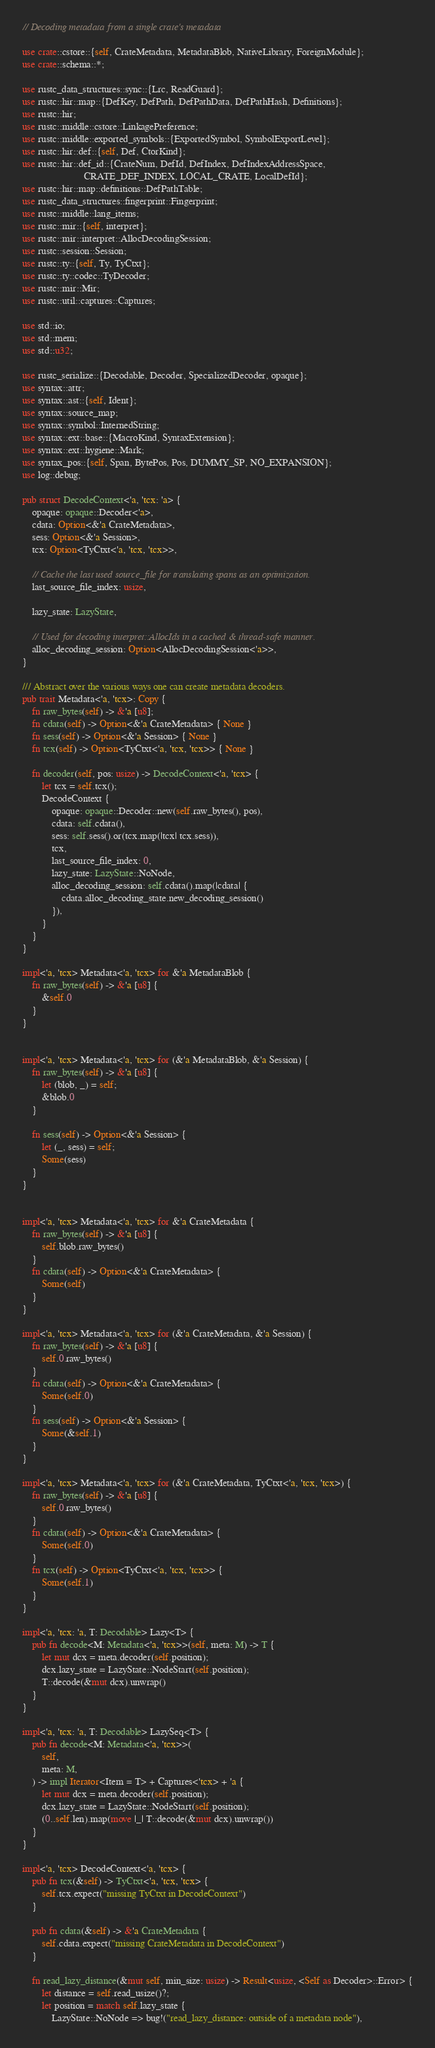Convert code to text. <code><loc_0><loc_0><loc_500><loc_500><_Rust_>// Decoding metadata from a single crate's metadata

use crate::cstore::{self, CrateMetadata, MetadataBlob, NativeLibrary, ForeignModule};
use crate::schema::*;

use rustc_data_structures::sync::{Lrc, ReadGuard};
use rustc::hir::map::{DefKey, DefPath, DefPathData, DefPathHash, Definitions};
use rustc::hir;
use rustc::middle::cstore::LinkagePreference;
use rustc::middle::exported_symbols::{ExportedSymbol, SymbolExportLevel};
use rustc::hir::def::{self, Def, CtorKind};
use rustc::hir::def_id::{CrateNum, DefId, DefIndex, DefIndexAddressSpace,
                         CRATE_DEF_INDEX, LOCAL_CRATE, LocalDefId};
use rustc::hir::map::definitions::DefPathTable;
use rustc_data_structures::fingerprint::Fingerprint;
use rustc::middle::lang_items;
use rustc::mir::{self, interpret};
use rustc::mir::interpret::AllocDecodingSession;
use rustc::session::Session;
use rustc::ty::{self, Ty, TyCtxt};
use rustc::ty::codec::TyDecoder;
use rustc::mir::Mir;
use rustc::util::captures::Captures;

use std::io;
use std::mem;
use std::u32;

use rustc_serialize::{Decodable, Decoder, SpecializedDecoder, opaque};
use syntax::attr;
use syntax::ast::{self, Ident};
use syntax::source_map;
use syntax::symbol::InternedString;
use syntax::ext::base::{MacroKind, SyntaxExtension};
use syntax::ext::hygiene::Mark;
use syntax_pos::{self, Span, BytePos, Pos, DUMMY_SP, NO_EXPANSION};
use log::debug;

pub struct DecodeContext<'a, 'tcx: 'a> {
    opaque: opaque::Decoder<'a>,
    cdata: Option<&'a CrateMetadata>,
    sess: Option<&'a Session>,
    tcx: Option<TyCtxt<'a, 'tcx, 'tcx>>,

    // Cache the last used source_file for translating spans as an optimization.
    last_source_file_index: usize,

    lazy_state: LazyState,

    // Used for decoding interpret::AllocIds in a cached & thread-safe manner.
    alloc_decoding_session: Option<AllocDecodingSession<'a>>,
}

/// Abstract over the various ways one can create metadata decoders.
pub trait Metadata<'a, 'tcx>: Copy {
    fn raw_bytes(self) -> &'a [u8];
    fn cdata(self) -> Option<&'a CrateMetadata> { None }
    fn sess(self) -> Option<&'a Session> { None }
    fn tcx(self) -> Option<TyCtxt<'a, 'tcx, 'tcx>> { None }

    fn decoder(self, pos: usize) -> DecodeContext<'a, 'tcx> {
        let tcx = self.tcx();
        DecodeContext {
            opaque: opaque::Decoder::new(self.raw_bytes(), pos),
            cdata: self.cdata(),
            sess: self.sess().or(tcx.map(|tcx| tcx.sess)),
            tcx,
            last_source_file_index: 0,
            lazy_state: LazyState::NoNode,
            alloc_decoding_session: self.cdata().map(|cdata| {
                cdata.alloc_decoding_state.new_decoding_session()
            }),
        }
    }
}

impl<'a, 'tcx> Metadata<'a, 'tcx> for &'a MetadataBlob {
    fn raw_bytes(self) -> &'a [u8] {
        &self.0
    }
}


impl<'a, 'tcx> Metadata<'a, 'tcx> for (&'a MetadataBlob, &'a Session) {
    fn raw_bytes(self) -> &'a [u8] {
        let (blob, _) = self;
        &blob.0
    }

    fn sess(self) -> Option<&'a Session> {
        let (_, sess) = self;
        Some(sess)
    }
}


impl<'a, 'tcx> Metadata<'a, 'tcx> for &'a CrateMetadata {
    fn raw_bytes(self) -> &'a [u8] {
        self.blob.raw_bytes()
    }
    fn cdata(self) -> Option<&'a CrateMetadata> {
        Some(self)
    }
}

impl<'a, 'tcx> Metadata<'a, 'tcx> for (&'a CrateMetadata, &'a Session) {
    fn raw_bytes(self) -> &'a [u8] {
        self.0.raw_bytes()
    }
    fn cdata(self) -> Option<&'a CrateMetadata> {
        Some(self.0)
    }
    fn sess(self) -> Option<&'a Session> {
        Some(&self.1)
    }
}

impl<'a, 'tcx> Metadata<'a, 'tcx> for (&'a CrateMetadata, TyCtxt<'a, 'tcx, 'tcx>) {
    fn raw_bytes(self) -> &'a [u8] {
        self.0.raw_bytes()
    }
    fn cdata(self) -> Option<&'a CrateMetadata> {
        Some(self.0)
    }
    fn tcx(self) -> Option<TyCtxt<'a, 'tcx, 'tcx>> {
        Some(self.1)
    }
}

impl<'a, 'tcx: 'a, T: Decodable> Lazy<T> {
    pub fn decode<M: Metadata<'a, 'tcx>>(self, meta: M) -> T {
        let mut dcx = meta.decoder(self.position);
        dcx.lazy_state = LazyState::NodeStart(self.position);
        T::decode(&mut dcx).unwrap()
    }
}

impl<'a, 'tcx: 'a, T: Decodable> LazySeq<T> {
    pub fn decode<M: Metadata<'a, 'tcx>>(
        self,
        meta: M,
    ) -> impl Iterator<Item = T> + Captures<'tcx> + 'a {
        let mut dcx = meta.decoder(self.position);
        dcx.lazy_state = LazyState::NodeStart(self.position);
        (0..self.len).map(move |_| T::decode(&mut dcx).unwrap())
    }
}

impl<'a, 'tcx> DecodeContext<'a, 'tcx> {
    pub fn tcx(&self) -> TyCtxt<'a, 'tcx, 'tcx> {
        self.tcx.expect("missing TyCtxt in DecodeContext")
    }

    pub fn cdata(&self) -> &'a CrateMetadata {
        self.cdata.expect("missing CrateMetadata in DecodeContext")
    }

    fn read_lazy_distance(&mut self, min_size: usize) -> Result<usize, <Self as Decoder>::Error> {
        let distance = self.read_usize()?;
        let position = match self.lazy_state {
            LazyState::NoNode => bug!("read_lazy_distance: outside of a metadata node"),</code> 